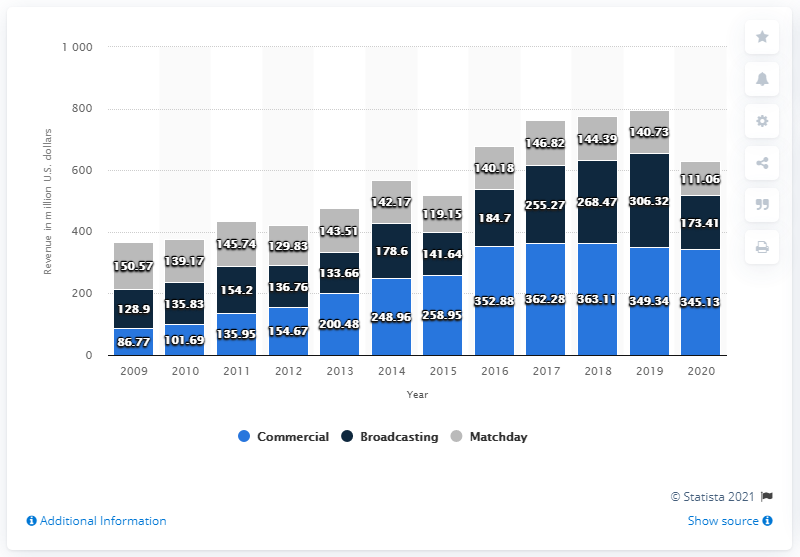Mention a couple of crucial points in this snapshot. In the fiscal year 2020, Manchester United generated a total of 111.06 million pounds in matchday revenue. 